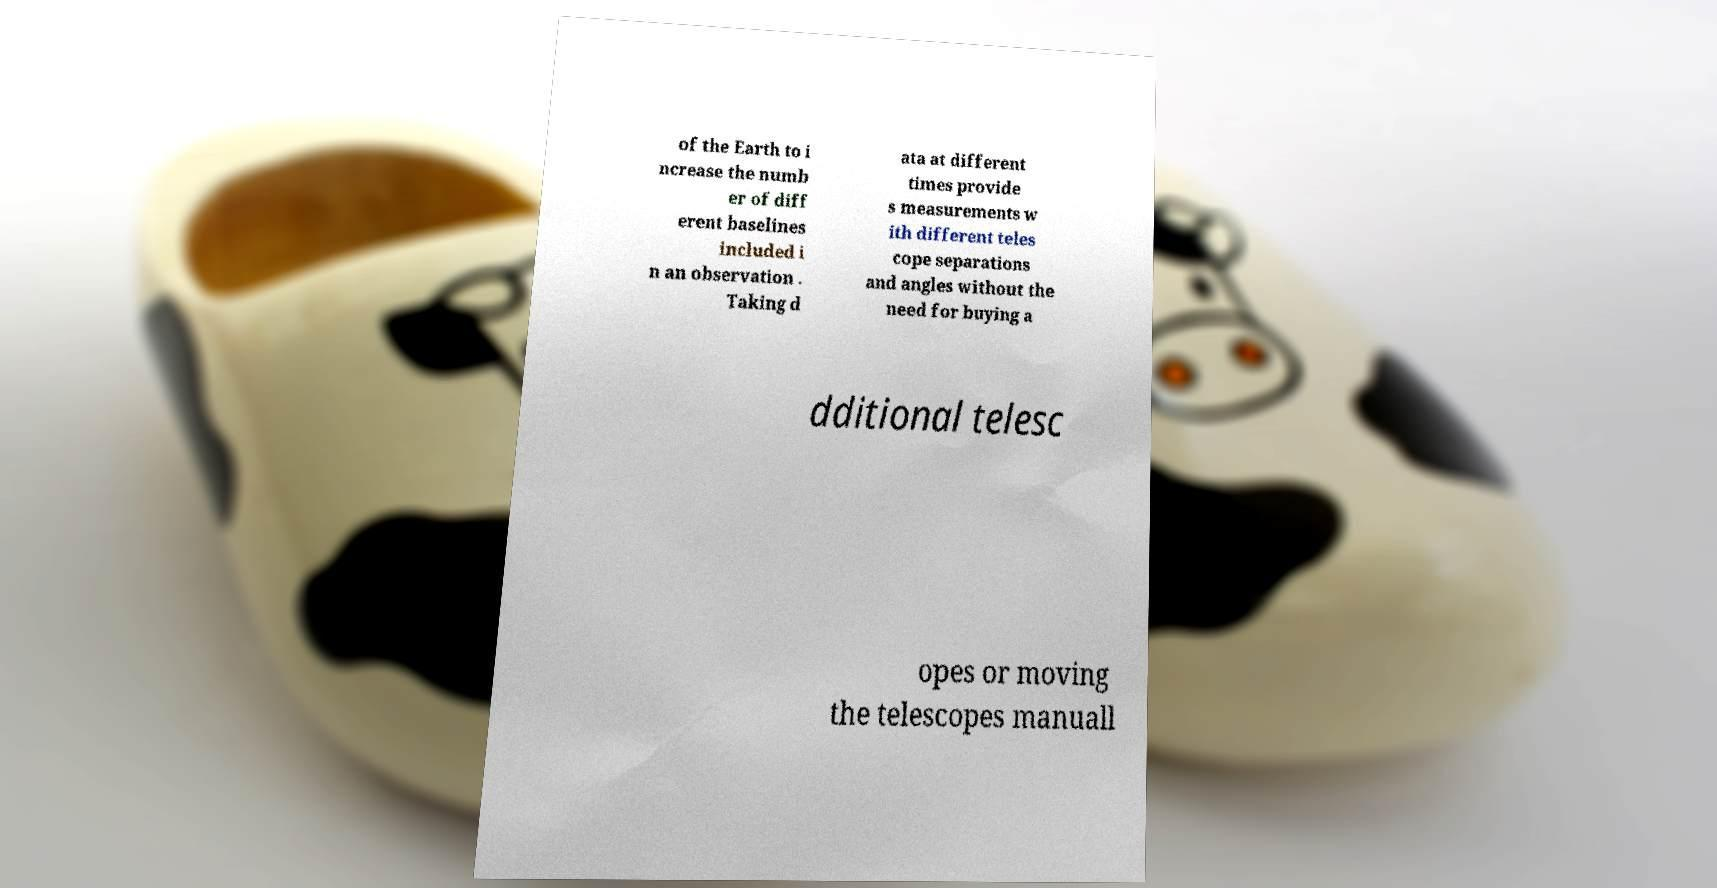I need the written content from this picture converted into text. Can you do that? of the Earth to i ncrease the numb er of diff erent baselines included i n an observation . Taking d ata at different times provide s measurements w ith different teles cope separations and angles without the need for buying a dditional telesc opes or moving the telescopes manuall 